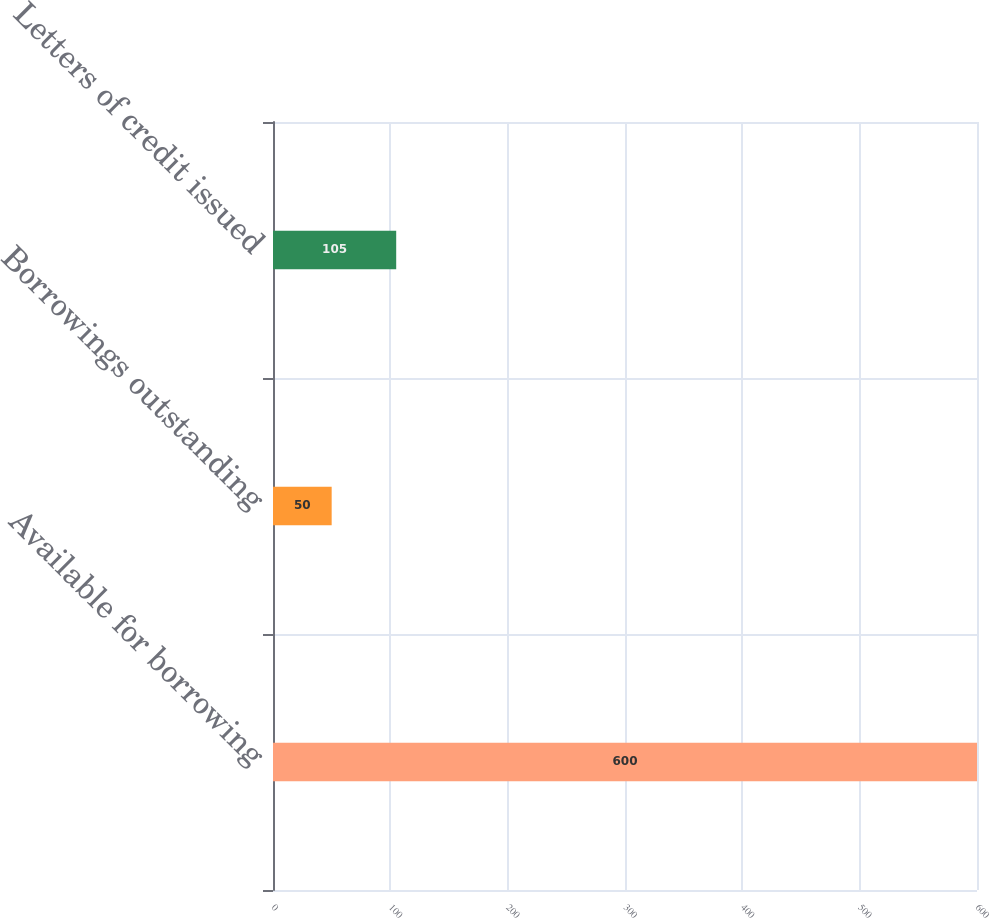<chart> <loc_0><loc_0><loc_500><loc_500><bar_chart><fcel>Available for borrowing<fcel>Borrowings outstanding<fcel>Letters of credit issued<nl><fcel>600<fcel>50<fcel>105<nl></chart> 